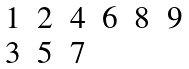<formula> <loc_0><loc_0><loc_500><loc_500>\begin{matrix} 1 & 2 & 4 & 6 & 8 & 9 \\ 3 & 5 & 7 & & & \\ \end{matrix}</formula> 